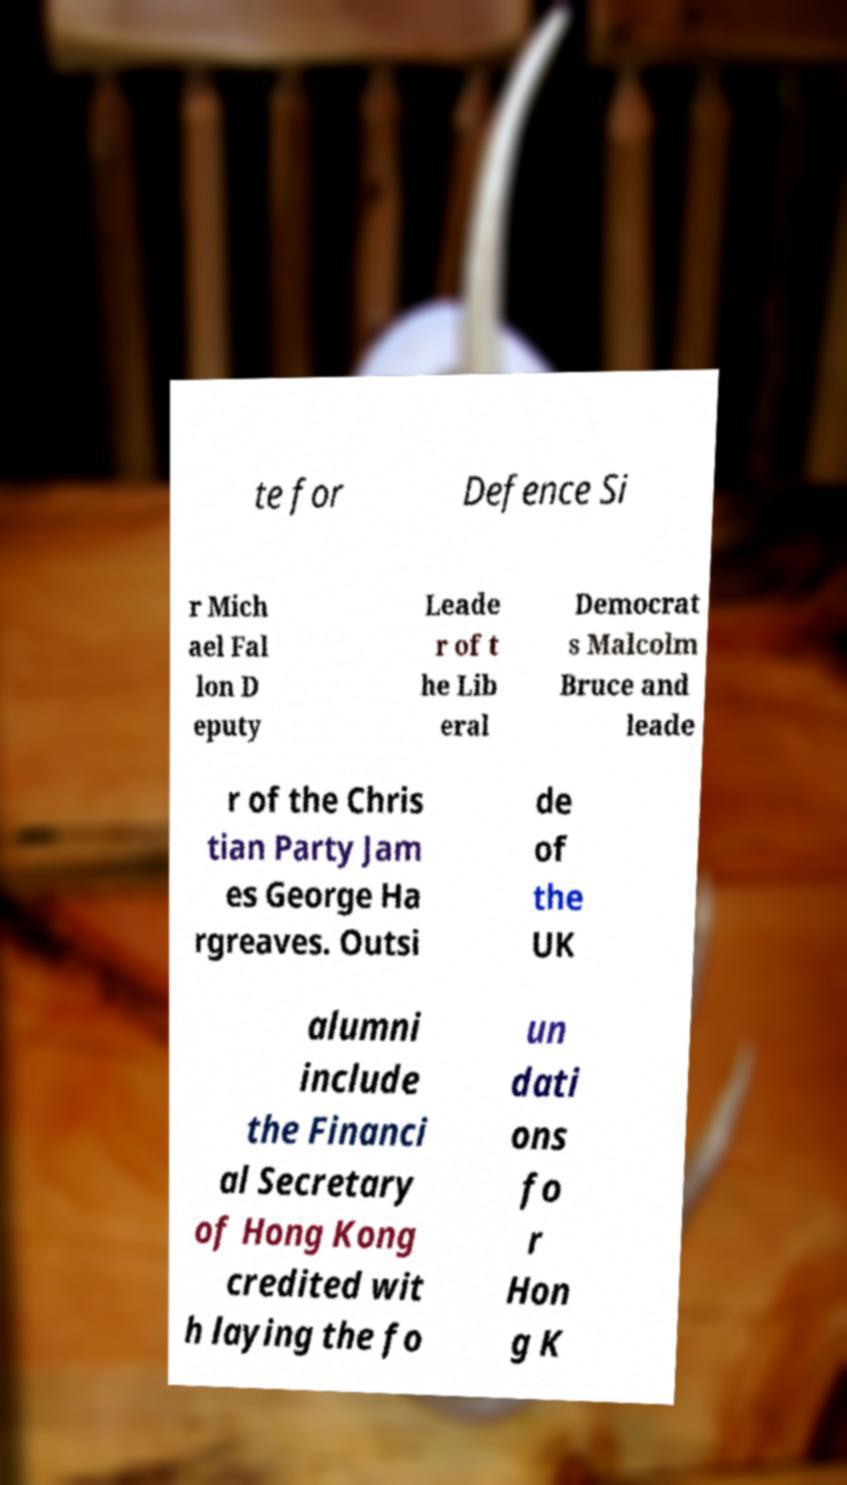Could you assist in decoding the text presented in this image and type it out clearly? te for Defence Si r Mich ael Fal lon D eputy Leade r of t he Lib eral Democrat s Malcolm Bruce and leade r of the Chris tian Party Jam es George Ha rgreaves. Outsi de of the UK alumni include the Financi al Secretary of Hong Kong credited wit h laying the fo un dati ons fo r Hon g K 